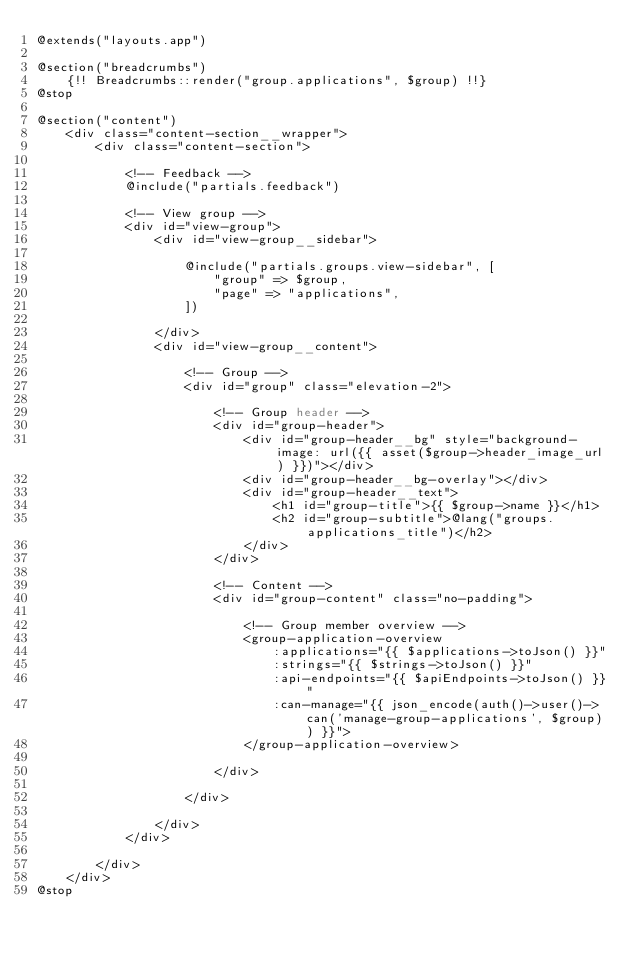Convert code to text. <code><loc_0><loc_0><loc_500><loc_500><_PHP_>@extends("layouts.app")

@section("breadcrumbs")
    {!! Breadcrumbs::render("group.applications", $group) !!}
@stop

@section("content")
    <div class="content-section__wrapper">
        <div class="content-section">

            <!-- Feedback -->
            @include("partials.feedback")

            <!-- View group -->
            <div id="view-group">
                <div id="view-group__sidebar">

                    @include("partials.groups.view-sidebar", [
                        "group" => $group,
                        "page" => "applications",
                    ])

                </div>
                <div id="view-group__content">

                    <!-- Group -->
                    <div id="group" class="elevation-2">

                        <!-- Group header -->
                        <div id="group-header">
                            <div id="group-header__bg" style="background-image: url({{ asset($group->header_image_url) }})"></div>
                            <div id="group-header__bg-overlay"></div>
                            <div id="group-header__text">
                                <h1 id="group-title">{{ $group->name }}</h1>
                                <h2 id="group-subtitle">@lang("groups.applications_title")</h2>
                            </div>
                        </div>

                        <!-- Content -->
                        <div id="group-content" class="no-padding">

                            <!-- Group member overview -->
                            <group-application-overview
                                :applications="{{ $applications->toJson() }}"
                                :strings="{{ $strings->toJson() }}"
                                :api-endpoints="{{ $apiEndpoints->toJson() }}"
                                :can-manage="{{ json_encode(auth()->user()->can('manage-group-applications', $group)) }}">
                            </group-application-overview>

                        </div>

                    </div>

                </div>
            </div>

        </div>
    </div>
@stop</code> 